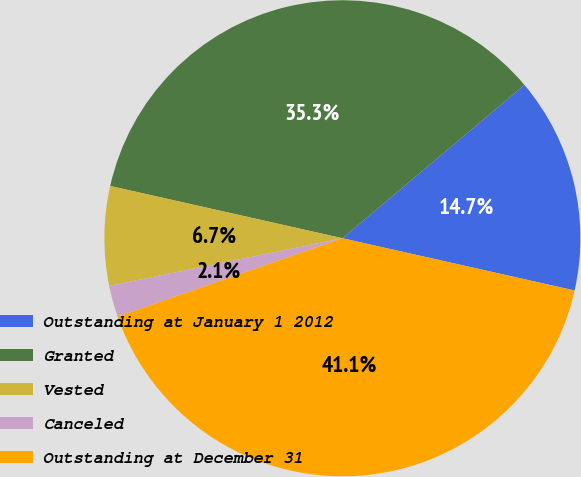Convert chart. <chart><loc_0><loc_0><loc_500><loc_500><pie_chart><fcel>Outstanding at January 1 2012<fcel>Granted<fcel>Vested<fcel>Canceled<fcel>Outstanding at December 31<nl><fcel>14.66%<fcel>35.34%<fcel>6.73%<fcel>2.14%<fcel>41.13%<nl></chart> 